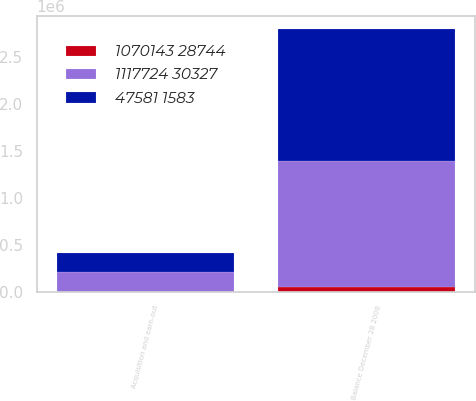Convert chart. <chart><loc_0><loc_0><loc_500><loc_500><stacked_bar_chart><ecel><fcel>Acquisition and earn-out<fcel>Balance December 28 2008<nl><fcel>1117724 30327<fcel>208196<fcel>1.34544e+06<nl><fcel>1070143 28744<fcel>591<fcel>50850<nl><fcel>47581 1583<fcel>207605<fcel>1.39629e+06<nl></chart> 